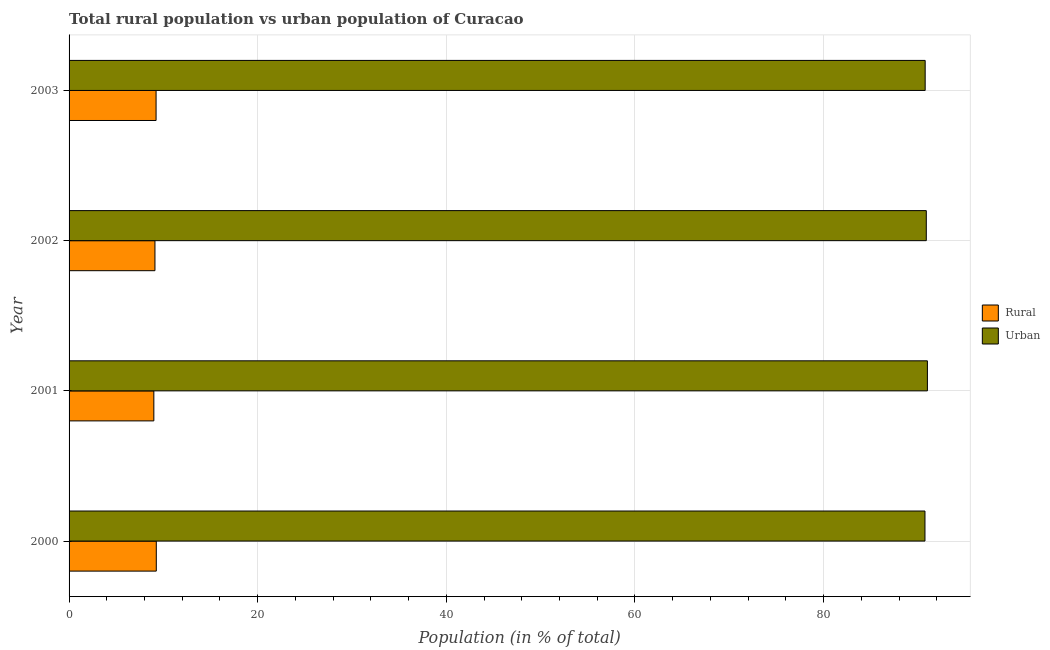How many groups of bars are there?
Your answer should be compact. 4. Are the number of bars per tick equal to the number of legend labels?
Ensure brevity in your answer.  Yes. Are the number of bars on each tick of the Y-axis equal?
Your response must be concise. Yes. How many bars are there on the 4th tick from the top?
Give a very brief answer. 2. How many bars are there on the 2nd tick from the bottom?
Provide a succinct answer. 2. In how many cases, is the number of bars for a given year not equal to the number of legend labels?
Your answer should be compact. 0. What is the rural population in 2003?
Your response must be concise. 9.22. Across all years, what is the maximum rural population?
Your answer should be compact. 9.25. Across all years, what is the minimum rural population?
Your answer should be compact. 8.99. In which year was the urban population maximum?
Give a very brief answer. 2001. What is the total rural population in the graph?
Offer a very short reply. 36.57. What is the difference between the rural population in 2000 and that in 2001?
Provide a short and direct response. 0.26. What is the difference between the urban population in 2002 and the rural population in 2001?
Ensure brevity in your answer.  81.91. What is the average rural population per year?
Ensure brevity in your answer.  9.14. In the year 2002, what is the difference between the rural population and urban population?
Your response must be concise. -81.79. In how many years, is the urban population greater than 16 %?
Give a very brief answer. 4. What is the ratio of the rural population in 2000 to that in 2002?
Make the answer very short. 1.02. What is the difference between the highest and the second highest rural population?
Provide a short and direct response. 0.02. What is the difference between the highest and the lowest urban population?
Offer a terse response. 0.26. In how many years, is the rural population greater than the average rural population taken over all years?
Give a very brief answer. 2. Is the sum of the urban population in 2000 and 2003 greater than the maximum rural population across all years?
Keep it short and to the point. Yes. What does the 2nd bar from the top in 2003 represents?
Your answer should be compact. Rural. What does the 2nd bar from the bottom in 2000 represents?
Your answer should be compact. Urban. How many bars are there?
Give a very brief answer. 8. How many years are there in the graph?
Provide a short and direct response. 4. Are the values on the major ticks of X-axis written in scientific E-notation?
Ensure brevity in your answer.  No. Does the graph contain any zero values?
Make the answer very short. No. Does the graph contain grids?
Your answer should be very brief. Yes. How are the legend labels stacked?
Give a very brief answer. Vertical. What is the title of the graph?
Make the answer very short. Total rural population vs urban population of Curacao. Does "Sanitation services" appear as one of the legend labels in the graph?
Provide a succinct answer. No. What is the label or title of the X-axis?
Offer a very short reply. Population (in % of total). What is the Population (in % of total) of Rural in 2000?
Offer a terse response. 9.25. What is the Population (in % of total) in Urban in 2000?
Provide a succinct answer. 90.75. What is the Population (in % of total) of Rural in 2001?
Give a very brief answer. 8.99. What is the Population (in % of total) of Urban in 2001?
Your answer should be compact. 91.01. What is the Population (in % of total) in Rural in 2002?
Make the answer very short. 9.11. What is the Population (in % of total) in Urban in 2002?
Provide a succinct answer. 90.89. What is the Population (in % of total) of Rural in 2003?
Keep it short and to the point. 9.22. What is the Population (in % of total) in Urban in 2003?
Offer a very short reply. 90.78. Across all years, what is the maximum Population (in % of total) of Rural?
Your answer should be compact. 9.25. Across all years, what is the maximum Population (in % of total) in Urban?
Offer a terse response. 91.01. Across all years, what is the minimum Population (in % of total) of Rural?
Your answer should be compact. 8.99. Across all years, what is the minimum Population (in % of total) of Urban?
Your answer should be very brief. 90.75. What is the total Population (in % of total) in Rural in the graph?
Offer a very short reply. 36.57. What is the total Population (in % of total) of Urban in the graph?
Your answer should be very brief. 363.43. What is the difference between the Population (in % of total) of Rural in 2000 and that in 2001?
Offer a very short reply. 0.26. What is the difference between the Population (in % of total) of Urban in 2000 and that in 2001?
Provide a short and direct response. -0.26. What is the difference between the Population (in % of total) in Rural in 2000 and that in 2002?
Your response must be concise. 0.14. What is the difference between the Population (in % of total) of Urban in 2000 and that in 2002?
Your response must be concise. -0.14. What is the difference between the Population (in % of total) of Rural in 2000 and that in 2003?
Give a very brief answer. 0.02. What is the difference between the Population (in % of total) in Urban in 2000 and that in 2003?
Provide a succinct answer. -0.02. What is the difference between the Population (in % of total) in Rural in 2001 and that in 2002?
Ensure brevity in your answer.  -0.12. What is the difference between the Population (in % of total) of Urban in 2001 and that in 2002?
Your response must be concise. 0.12. What is the difference between the Population (in % of total) of Rural in 2001 and that in 2003?
Keep it short and to the point. -0.24. What is the difference between the Population (in % of total) of Urban in 2001 and that in 2003?
Offer a very short reply. 0.24. What is the difference between the Population (in % of total) in Rural in 2002 and that in 2003?
Keep it short and to the point. -0.12. What is the difference between the Population (in % of total) in Urban in 2002 and that in 2003?
Ensure brevity in your answer.  0.12. What is the difference between the Population (in % of total) in Rural in 2000 and the Population (in % of total) in Urban in 2001?
Provide a short and direct response. -81.76. What is the difference between the Population (in % of total) of Rural in 2000 and the Population (in % of total) of Urban in 2002?
Offer a terse response. -81.65. What is the difference between the Population (in % of total) in Rural in 2000 and the Population (in % of total) in Urban in 2003?
Your answer should be compact. -81.53. What is the difference between the Population (in % of total) in Rural in 2001 and the Population (in % of total) in Urban in 2002?
Give a very brief answer. -81.91. What is the difference between the Population (in % of total) of Rural in 2001 and the Population (in % of total) of Urban in 2003?
Offer a terse response. -81.79. What is the difference between the Population (in % of total) of Rural in 2002 and the Population (in % of total) of Urban in 2003?
Your answer should be very brief. -81.67. What is the average Population (in % of total) in Rural per year?
Give a very brief answer. 9.14. What is the average Population (in % of total) of Urban per year?
Keep it short and to the point. 90.86. In the year 2000, what is the difference between the Population (in % of total) of Rural and Population (in % of total) of Urban?
Offer a very short reply. -81.5. In the year 2001, what is the difference between the Population (in % of total) in Rural and Population (in % of total) in Urban?
Offer a very short reply. -82.02. In the year 2002, what is the difference between the Population (in % of total) in Rural and Population (in % of total) in Urban?
Ensure brevity in your answer.  -81.79. In the year 2003, what is the difference between the Population (in % of total) of Rural and Population (in % of total) of Urban?
Ensure brevity in your answer.  -81.55. What is the ratio of the Population (in % of total) of Rural in 2000 to that in 2001?
Keep it short and to the point. 1.03. What is the ratio of the Population (in % of total) in Rural in 2000 to that in 2002?
Keep it short and to the point. 1.02. What is the ratio of the Population (in % of total) in Urban in 2000 to that in 2002?
Offer a very short reply. 1. What is the ratio of the Population (in % of total) of Rural in 2000 to that in 2003?
Make the answer very short. 1. What is the ratio of the Population (in % of total) of Rural in 2001 to that in 2002?
Offer a terse response. 0.99. What is the ratio of the Population (in % of total) of Urban in 2001 to that in 2002?
Provide a short and direct response. 1. What is the ratio of the Population (in % of total) in Rural in 2001 to that in 2003?
Keep it short and to the point. 0.97. What is the ratio of the Population (in % of total) of Urban in 2001 to that in 2003?
Give a very brief answer. 1. What is the ratio of the Population (in % of total) in Rural in 2002 to that in 2003?
Your response must be concise. 0.99. What is the ratio of the Population (in % of total) of Urban in 2002 to that in 2003?
Offer a very short reply. 1. What is the difference between the highest and the second highest Population (in % of total) of Rural?
Your answer should be compact. 0.02. What is the difference between the highest and the second highest Population (in % of total) in Urban?
Your answer should be very brief. 0.12. What is the difference between the highest and the lowest Population (in % of total) in Rural?
Your response must be concise. 0.26. What is the difference between the highest and the lowest Population (in % of total) in Urban?
Your answer should be very brief. 0.26. 